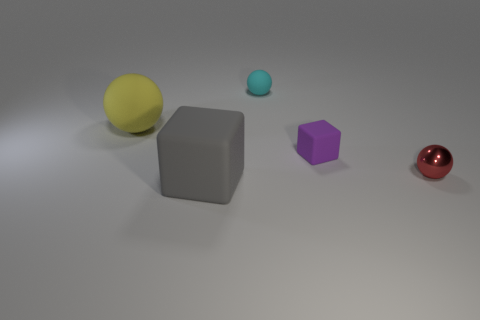Are the object in front of the tiny red object and the large object that is behind the small purple matte thing made of the same material?
Give a very brief answer. Yes. Is there any other thing that is the same shape as the red object?
Provide a succinct answer. Yes. What is the color of the large matte cube?
Provide a succinct answer. Gray. What number of big matte objects are the same shape as the metal object?
Keep it short and to the point. 1. There is a shiny sphere that is the same size as the purple object; what is its color?
Offer a terse response. Red. Is there a gray rubber cube?
Provide a short and direct response. Yes. There is a large matte thing that is behind the tiny red metallic ball; what shape is it?
Your answer should be compact. Sphere. What number of things are both right of the big gray object and behind the red shiny ball?
Your response must be concise. 2. Is there a tiny purple cube made of the same material as the yellow thing?
Give a very brief answer. Yes. How many cylinders are either yellow things or metal objects?
Offer a terse response. 0. 